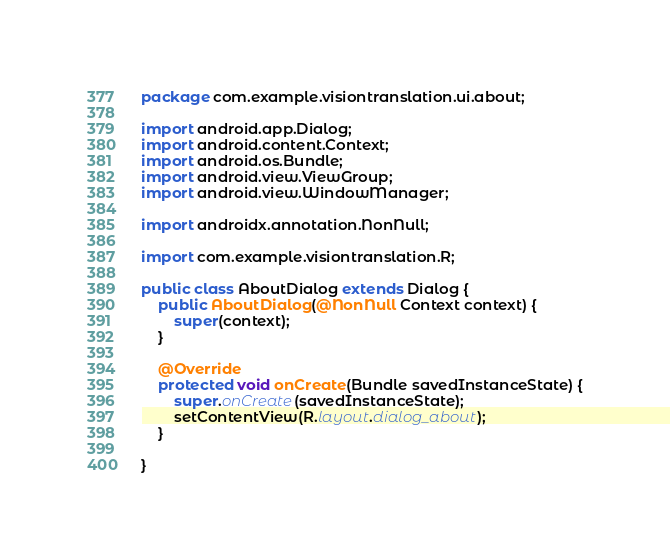Convert code to text. <code><loc_0><loc_0><loc_500><loc_500><_Java_>package com.example.visiontranslation.ui.about;

import android.app.Dialog;
import android.content.Context;
import android.os.Bundle;
import android.view.ViewGroup;
import android.view.WindowManager;

import androidx.annotation.NonNull;

import com.example.visiontranslation.R;

public class AboutDialog extends Dialog {
    public AboutDialog(@NonNull Context context) {
        super(context);
    }

    @Override
    protected void onCreate(Bundle savedInstanceState) {
        super.onCreate(savedInstanceState);
        setContentView(R.layout.dialog_about);
    }

}
</code> 